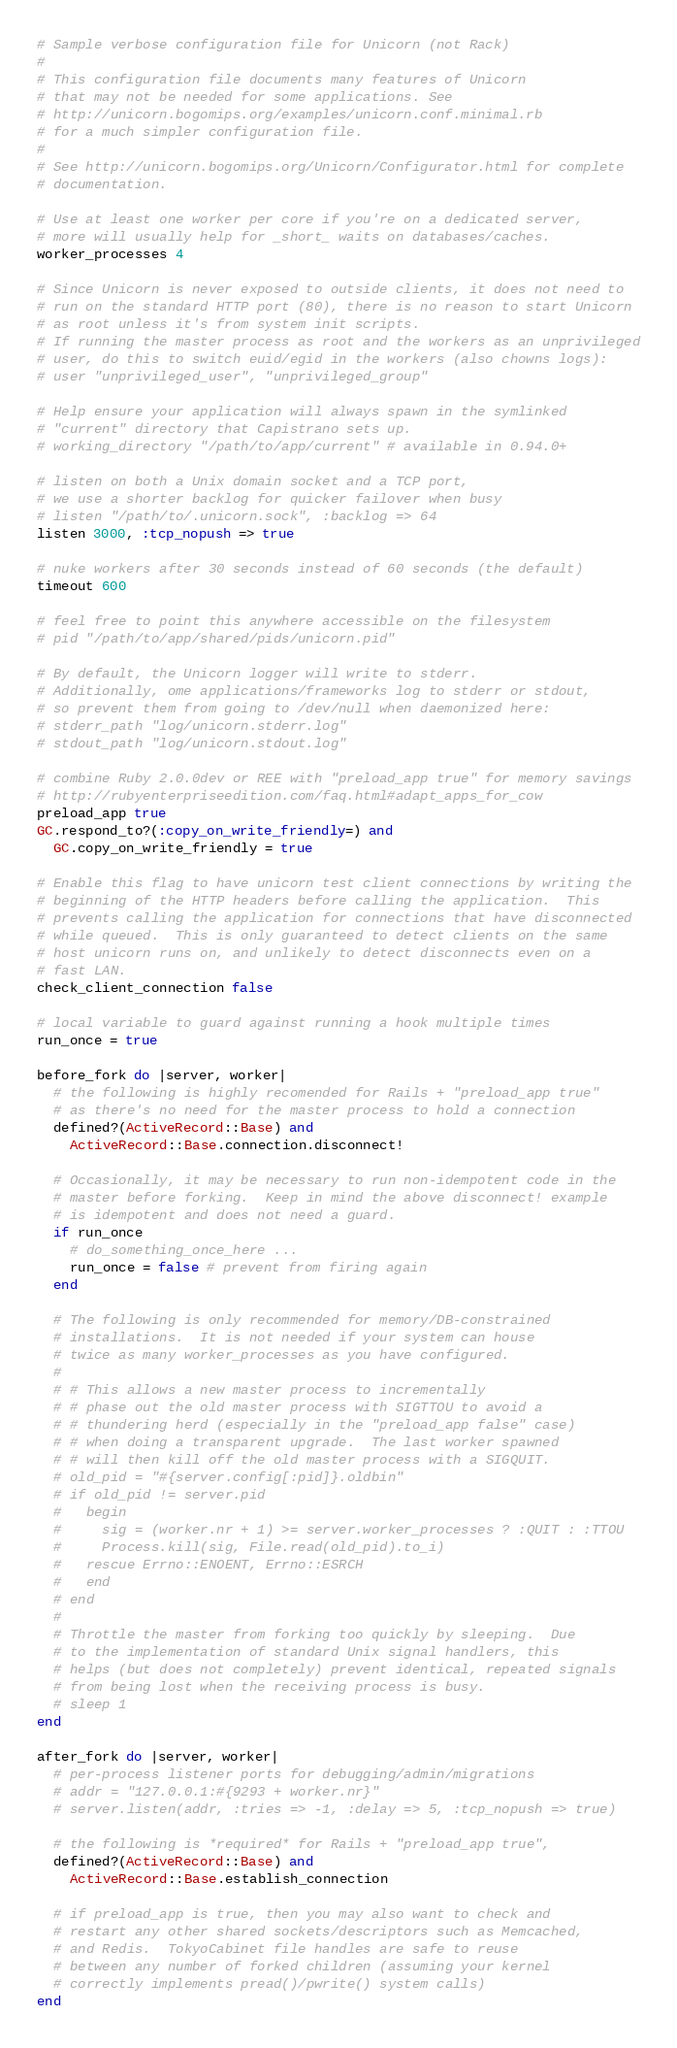Convert code to text. <code><loc_0><loc_0><loc_500><loc_500><_Ruby_># Sample verbose configuration file for Unicorn (not Rack)
#
# This configuration file documents many features of Unicorn
# that may not be needed for some applications. See
# http://unicorn.bogomips.org/examples/unicorn.conf.minimal.rb
# for a much simpler configuration file.
#
# See http://unicorn.bogomips.org/Unicorn/Configurator.html for complete
# documentation.

# Use at least one worker per core if you're on a dedicated server,
# more will usually help for _short_ waits on databases/caches.
worker_processes 4

# Since Unicorn is never exposed to outside clients, it does not need to
# run on the standard HTTP port (80), there is no reason to start Unicorn
# as root unless it's from system init scripts.
# If running the master process as root and the workers as an unprivileged
# user, do this to switch euid/egid in the workers (also chowns logs):
# user "unprivileged_user", "unprivileged_group"

# Help ensure your application will always spawn in the symlinked
# "current" directory that Capistrano sets up.
# working_directory "/path/to/app/current" # available in 0.94.0+

# listen on both a Unix domain socket and a TCP port,
# we use a shorter backlog for quicker failover when busy
# listen "/path/to/.unicorn.sock", :backlog => 64
listen 3000, :tcp_nopush => true

# nuke workers after 30 seconds instead of 60 seconds (the default)
timeout 600

# feel free to point this anywhere accessible on the filesystem
# pid "/path/to/app/shared/pids/unicorn.pid"

# By default, the Unicorn logger will write to stderr.
# Additionally, ome applications/frameworks log to stderr or stdout,
# so prevent them from going to /dev/null when daemonized here:
# stderr_path "log/unicorn.stderr.log"
# stdout_path "log/unicorn.stdout.log"

# combine Ruby 2.0.0dev or REE with "preload_app true" for memory savings
# http://rubyenterpriseedition.com/faq.html#adapt_apps_for_cow
preload_app true
GC.respond_to?(:copy_on_write_friendly=) and
  GC.copy_on_write_friendly = true

# Enable this flag to have unicorn test client connections by writing the
# beginning of the HTTP headers before calling the application.  This
# prevents calling the application for connections that have disconnected
# while queued.  This is only guaranteed to detect clients on the same
# host unicorn runs on, and unlikely to detect disconnects even on a
# fast LAN.
check_client_connection false

# local variable to guard against running a hook multiple times
run_once = true

before_fork do |server, worker|
  # the following is highly recomended for Rails + "preload_app true"
  # as there's no need for the master process to hold a connection
  defined?(ActiveRecord::Base) and
    ActiveRecord::Base.connection.disconnect!

  # Occasionally, it may be necessary to run non-idempotent code in the
  # master before forking.  Keep in mind the above disconnect! example
  # is idempotent and does not need a guard.
  if run_once
    # do_something_once_here ...
    run_once = false # prevent from firing again
  end

  # The following is only recommended for memory/DB-constrained
  # installations.  It is not needed if your system can house
  # twice as many worker_processes as you have configured.
  #
  # # This allows a new master process to incrementally
  # # phase out the old master process with SIGTTOU to avoid a
  # # thundering herd (especially in the "preload_app false" case)
  # # when doing a transparent upgrade.  The last worker spawned
  # # will then kill off the old master process with a SIGQUIT.
  # old_pid = "#{server.config[:pid]}.oldbin"
  # if old_pid != server.pid
  #   begin
  #     sig = (worker.nr + 1) >= server.worker_processes ? :QUIT : :TTOU
  #     Process.kill(sig, File.read(old_pid).to_i)
  #   rescue Errno::ENOENT, Errno::ESRCH
  #   end
  # end
  #
  # Throttle the master from forking too quickly by sleeping.  Due
  # to the implementation of standard Unix signal handlers, this
  # helps (but does not completely) prevent identical, repeated signals
  # from being lost when the receiving process is busy.
  # sleep 1
end

after_fork do |server, worker|
  # per-process listener ports for debugging/admin/migrations
  # addr = "127.0.0.1:#{9293 + worker.nr}"
  # server.listen(addr, :tries => -1, :delay => 5, :tcp_nopush => true)

  # the following is *required* for Rails + "preload_app true",
  defined?(ActiveRecord::Base) and
    ActiveRecord::Base.establish_connection

  # if preload_app is true, then you may also want to check and
  # restart any other shared sockets/descriptors such as Memcached,
  # and Redis.  TokyoCabinet file handles are safe to reuse
  # between any number of forked children (assuming your kernel
  # correctly implements pread()/pwrite() system calls)
end
</code> 